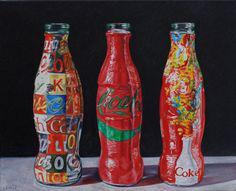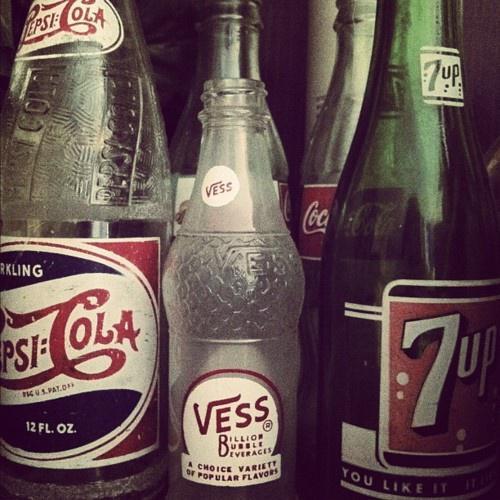The first image is the image on the left, the second image is the image on the right. Analyze the images presented: Is the assertion "The bottles in one of the images have been painted." valid? Answer yes or no. Yes. The first image is the image on the left, the second image is the image on the right. Analyze the images presented: Is the assertion "One image shows a group of overlapping old-fashioned glass soda bottles with a variety of labels, shapes and sizes." valid? Answer yes or no. Yes. 